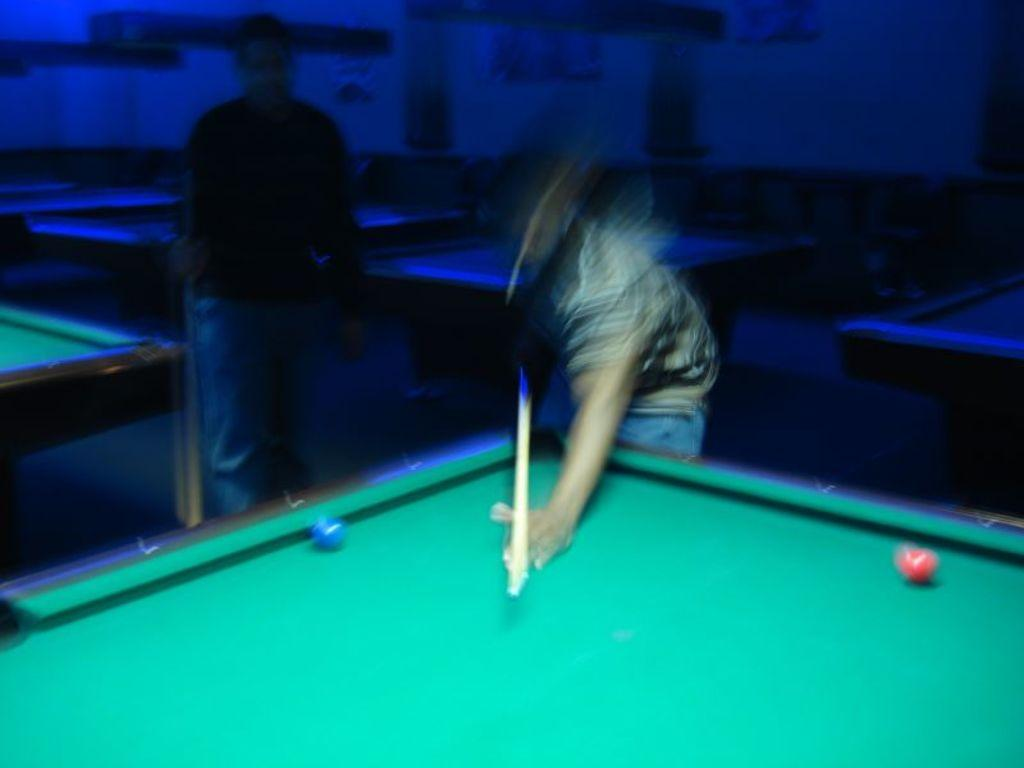What is the man in the image holding? The man is holding a stick in the image. Where is the stick located in relation to the man? The stick is in the man's hand. What is the man doing with the stick? The man is pointing at a ball on a snooker table. Can you describe the person standing in the image? There is a person standing in the image, but no specific details are provided. What is the color of the background in the image? The background of the image is dark. What type of tank is visible in the image? There is no tank present in the image. What is the reason for the man pointing at the ball on the snooker table? The facts provided do not give any information about the man's reason for pointing at the ball. 